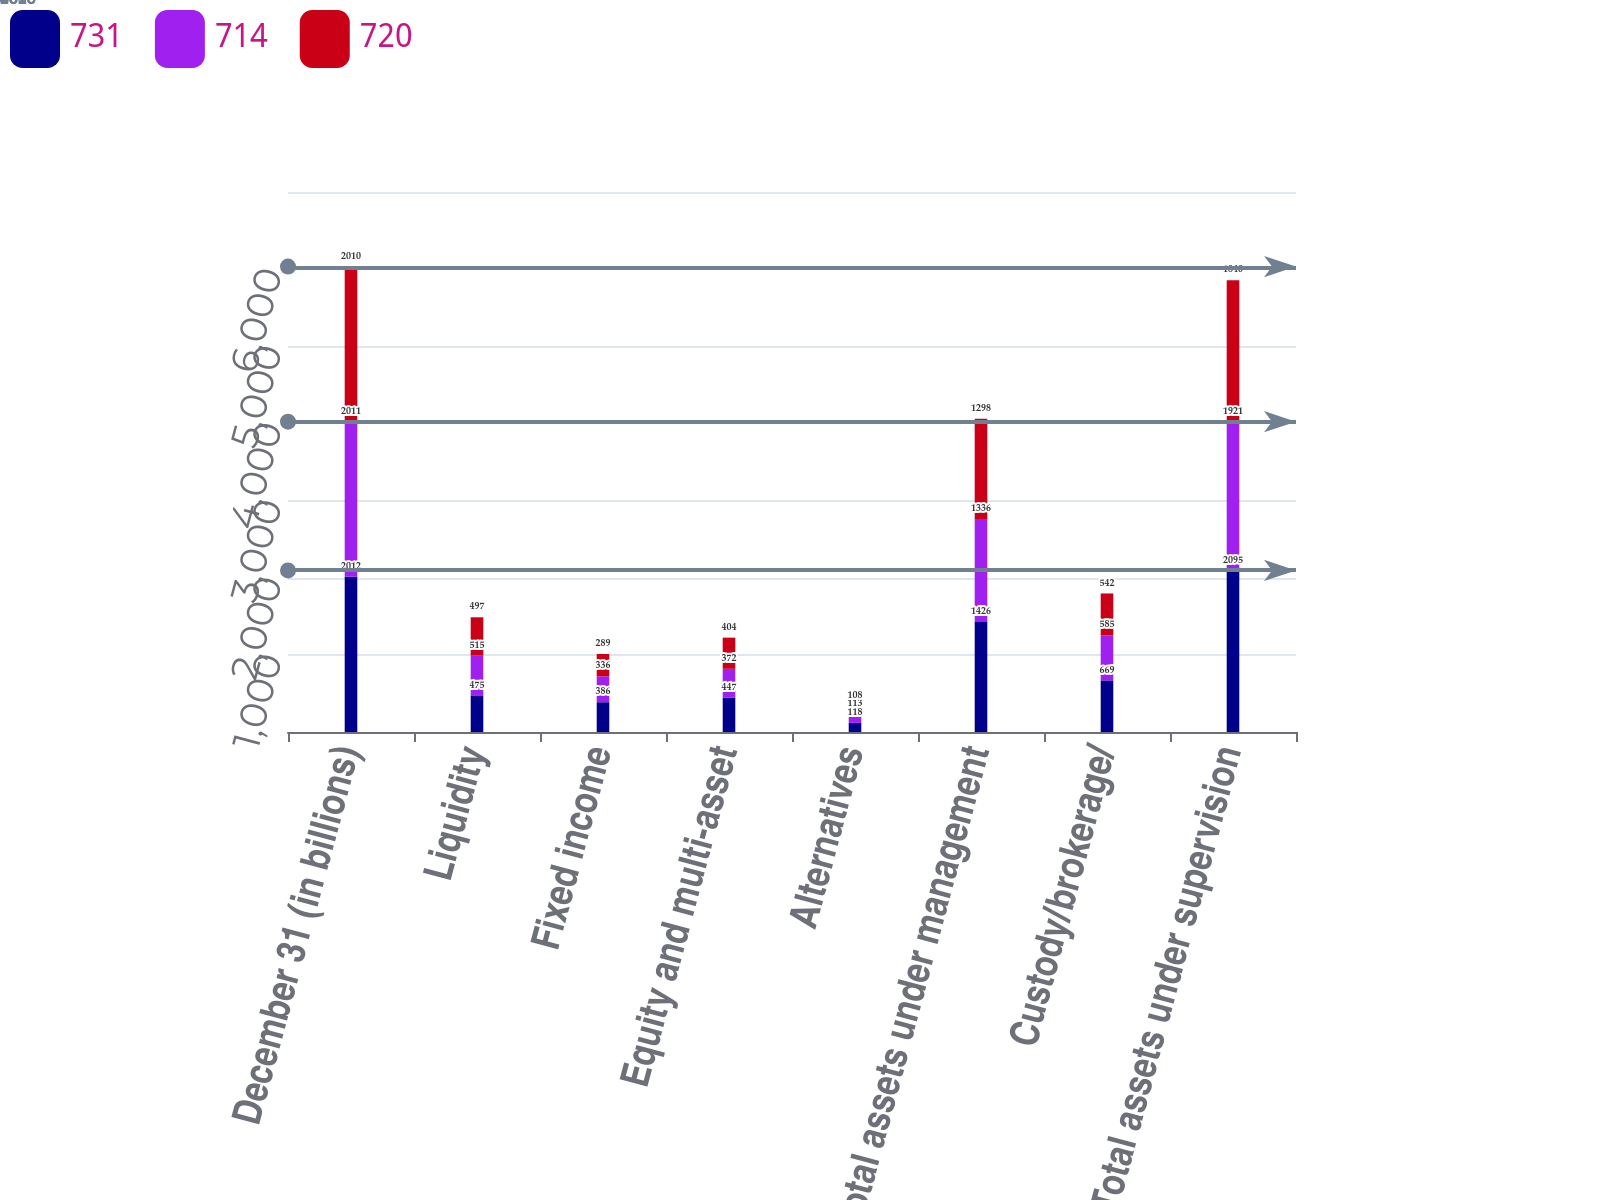Convert chart to OTSL. <chart><loc_0><loc_0><loc_500><loc_500><stacked_bar_chart><ecel><fcel>December 31 (in billions)<fcel>Liquidity<fcel>Fixed income<fcel>Equity and multi-asset<fcel>Alternatives<fcel>Total assets under management<fcel>Custody/brokerage/<fcel>Total assets under supervision<nl><fcel>731<fcel>2012<fcel>475<fcel>386<fcel>447<fcel>118<fcel>1426<fcel>669<fcel>2095<nl><fcel>714<fcel>2011<fcel>515<fcel>336<fcel>372<fcel>113<fcel>1336<fcel>585<fcel>1921<nl><fcel>720<fcel>2010<fcel>497<fcel>289<fcel>404<fcel>108<fcel>1298<fcel>542<fcel>1840<nl></chart> 